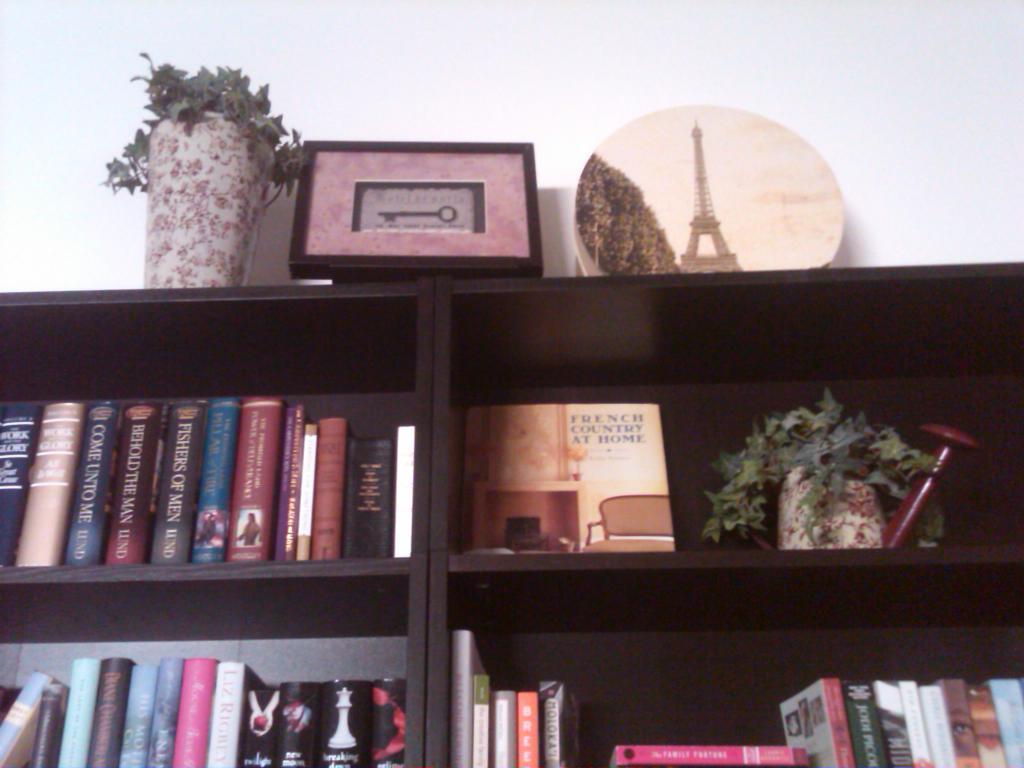What series of books are on the bottom shelf?
Offer a terse response. Unanswerable. What is the book beside the plant?
Offer a terse response. French country at home. 